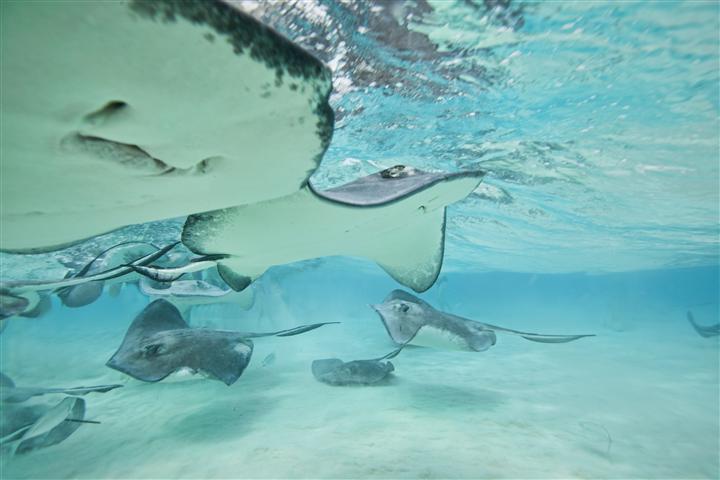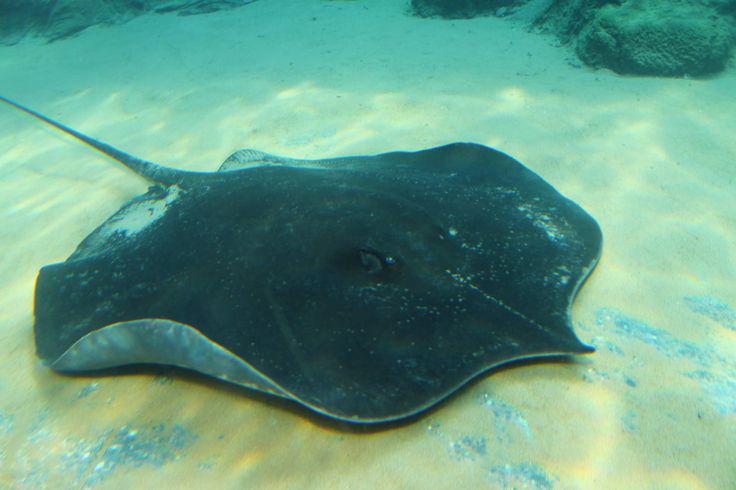The first image is the image on the left, the second image is the image on the right. Considering the images on both sides, is "The sting ray in the right picture is facing towards the left." valid? Answer yes or no. No. 